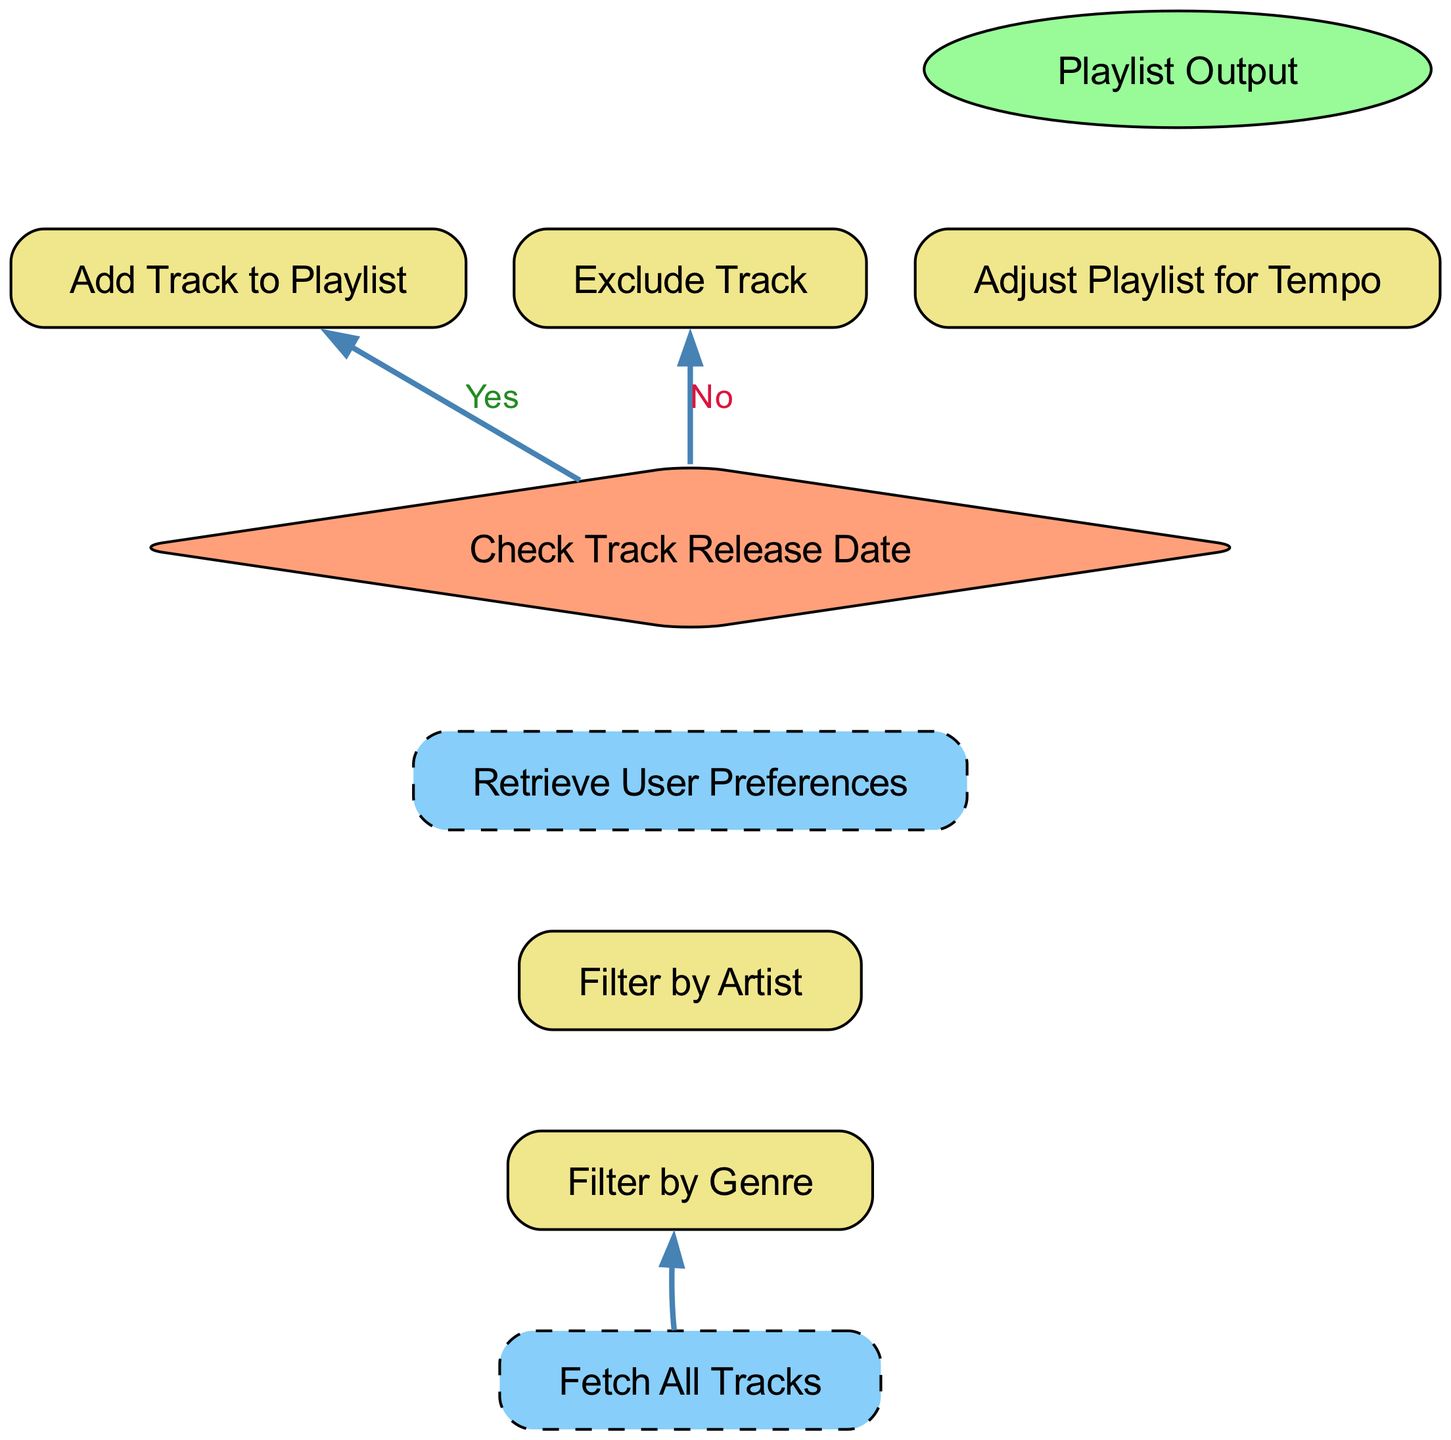What is the final output of the playlist curation system? The final output is represented by the node labeled "Playlist Output", which contains the curated classic hip hop tracks.
Answer: Playlist Output How many decision nodes are present in the flowchart? The flowchart has one decision node, which is the "Check Track Release Date" node, where the path diverges based on the release date of the track.
Answer: 1 What process occurs after filtering by genre? After filtering by genre, the next process is "Check Track Release Date" where tracks are evaluated based on their release dates.
Answer: Check Track Release Date If a track is released between 1980 and 2000, what happens next? If a track is released between 1980 and 2000, the system proceeds to "Add Track to Playlist", adding the valid track to the curated playlist.
Answer: Add Track to Playlist Which subprocess retrieves user preferences? The subprocess that retrieves user preferences is labeled "Retrieve User Preferences", which fetches details like favorite artists and preferred tempo for playlist adjustments.
Answer: Retrieve User Preferences If a track does not meet the release date criteria, what action is taken? If a track does not meet the release date criteria, the action taken is "Exclude Track", meaning it will not be added to the playlist.
Answer: Exclude Track What type of element is "Fetch All Tracks"? "Fetch All Tracks" is a subprocess, indicated by its node style which is dashed and filled, representing a step in fetching all available tracks for further processing.
Answer: subprocess What is the connection between "Adjust Playlist for Tempo" and "Playlist Output"? "Adjust Playlist for Tempo" leads directly to "Playlist Output", as the final adjustment step directly influences the final curated playlist output.
Answer: Direct connection Which process immediately follows "Filter by Artist"? The process that immediately follows "Filter by Artist" is "Retrieve User Preferences", indicating that user preferences are pulled right after filtering tracks by artist.
Answer: Retrieve User Preferences 